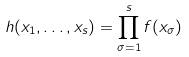<formula> <loc_0><loc_0><loc_500><loc_500>h ( x _ { 1 } , \dots , x _ { s } ) = \prod _ { \sigma = 1 } ^ { s } f ( x _ { \sigma } )</formula> 